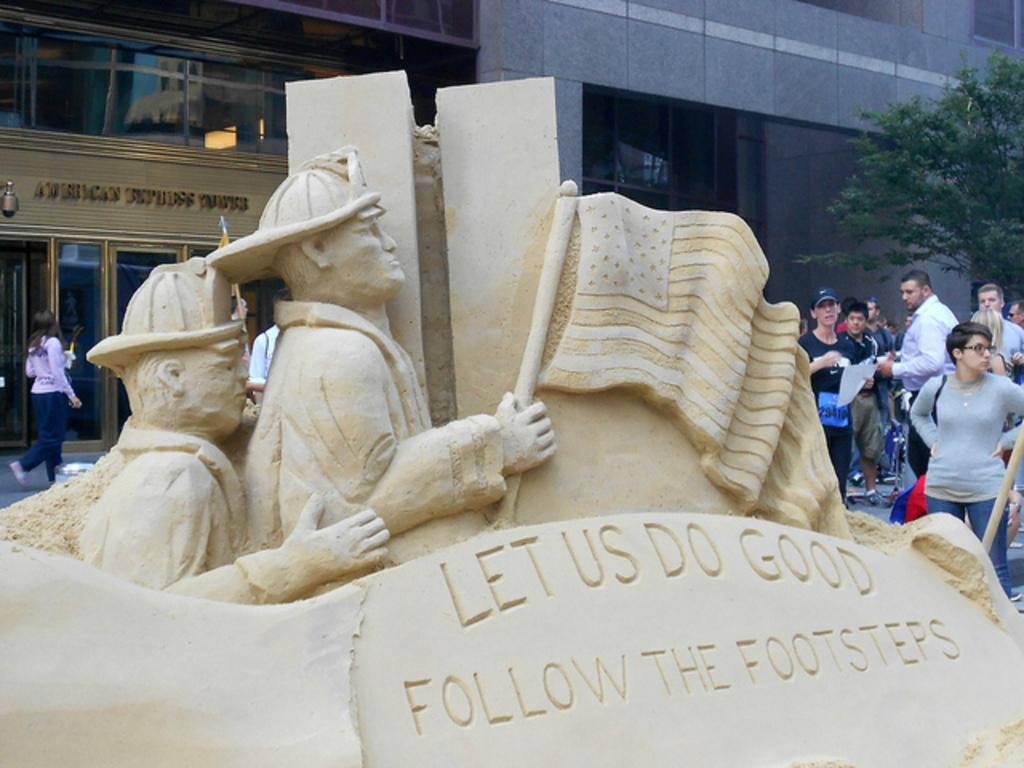What is the main subject in the center of the image? There is a statue in the center of the image. What can be seen in the background of the image? There is a building and trees in the background of the image. Are there any people visible in the image? Yes, there are persons in the background of the image. How many legs does the giraffe have in the image? There is no giraffe present in the image, so it is not possible to determine the number of legs it might have. 